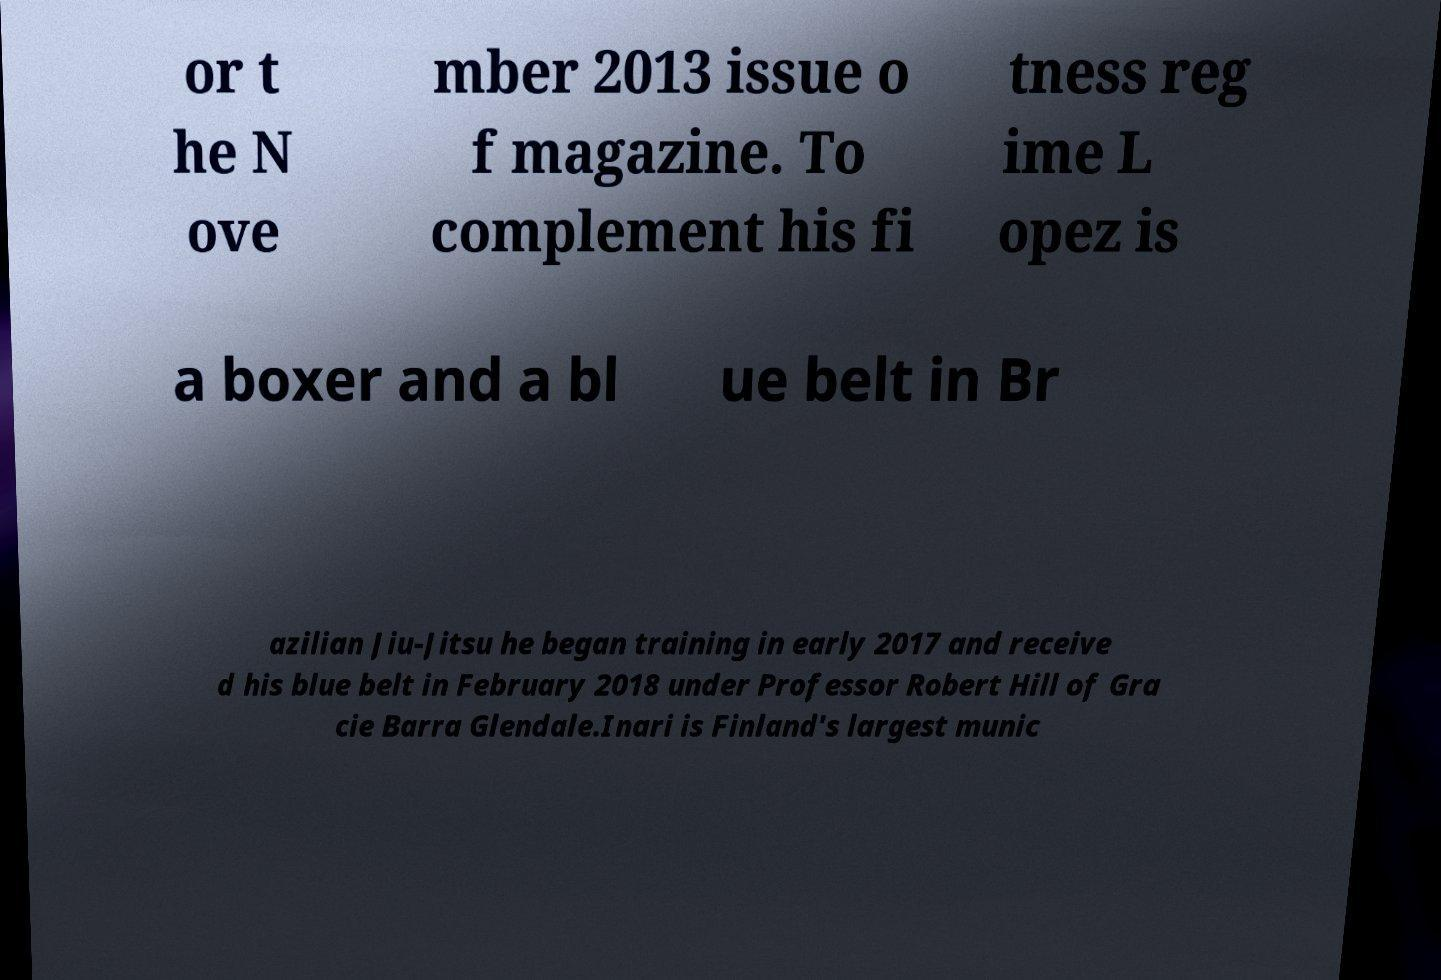What messages or text are displayed in this image? I need them in a readable, typed format. or t he N ove mber 2013 issue o f magazine. To complement his fi tness reg ime L opez is a boxer and a bl ue belt in Br azilian Jiu-Jitsu he began training in early 2017 and receive d his blue belt in February 2018 under Professor Robert Hill of Gra cie Barra Glendale.Inari is Finland's largest munic 